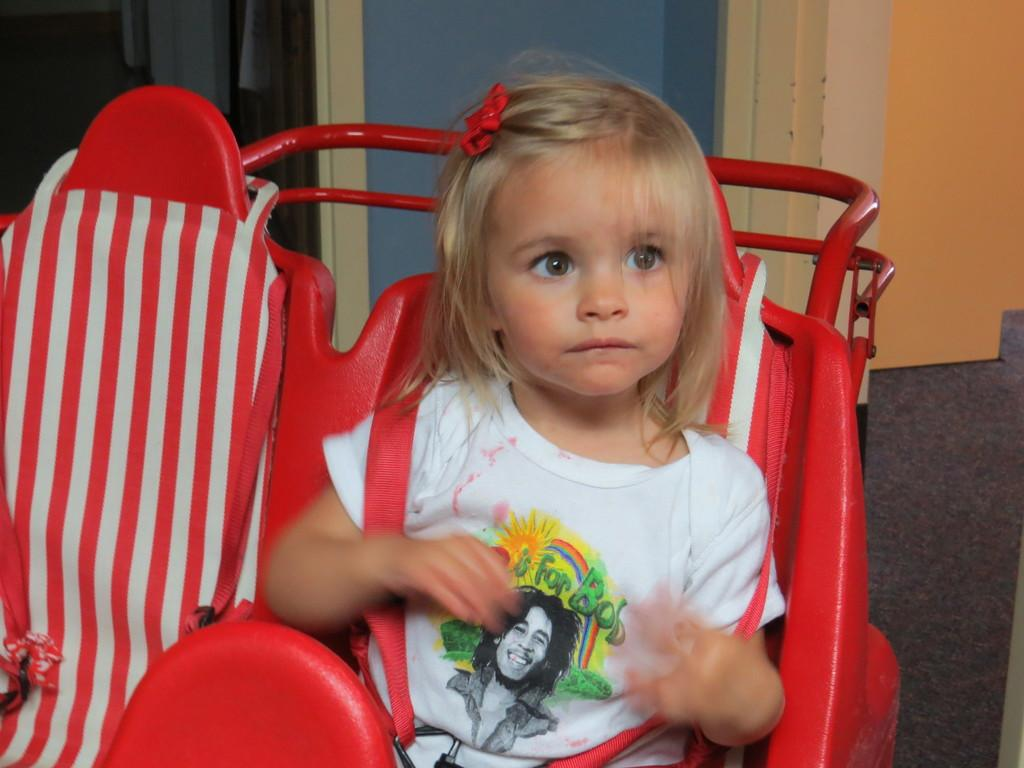Who is the main subject in the image? There is a girl in the image. What is the girl wearing? The girl is wearing a white t-shirt. What is the girl doing in the image? The girl is sitting in a toy vehicle. What color is the toy vehicle? The toy vehicle is red in color. What can be seen in the background of the image? There is a wall in the background of the image. What type of increase is the minister discussing with the farmer in the image? There is no minister or farmer present in the image, nor is there any discussion about an increase. 